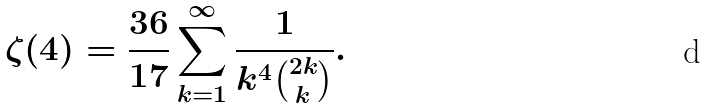Convert formula to latex. <formula><loc_0><loc_0><loc_500><loc_500>\zeta ( 4 ) = \frac { 3 6 } { 1 7 } \sum _ { k = 1 } ^ { \infty } \frac { 1 } { k ^ { 4 } \binom { 2 k } { k } } .</formula> 